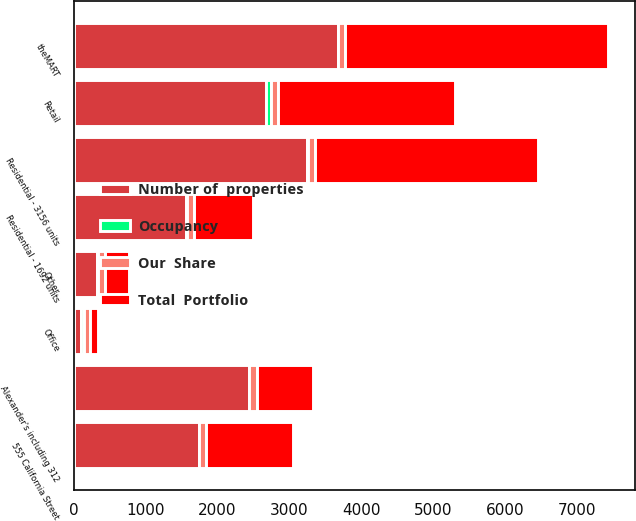Convert chart. <chart><loc_0><loc_0><loc_500><loc_500><stacked_bar_chart><ecel><fcel>Office<fcel>Retail<fcel>Residential - 1692 units<fcel>Alexander's including 312<fcel>Residential - 3156 units<fcel>Other<fcel>theMART<fcel>555 California Street<nl><fcel>Occupancy<fcel>36<fcel>70<fcel>11<fcel>7<fcel>9<fcel>5<fcel>3<fcel>3<nl><fcel>Number of  properties<fcel>99.9<fcel>2672<fcel>1559<fcel>2437<fcel>3245<fcel>330<fcel>3671<fcel>1738<nl><fcel>Total  Portfolio<fcel>99.9<fcel>2464<fcel>826<fcel>790<fcel>3103<fcel>330<fcel>3662<fcel>1217<nl><fcel>Our  Share<fcel>96.3<fcel>97.1<fcel>95.7<fcel>99.8<fcel>97.8<fcel>100<fcel>98.9<fcel>92.4<nl></chart> 